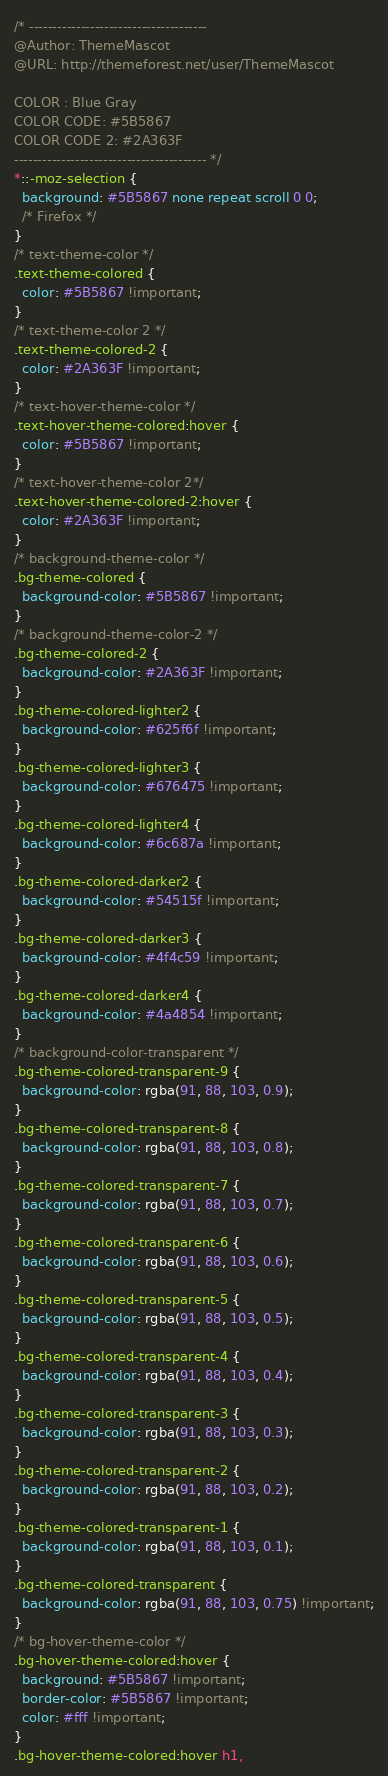Convert code to text. <code><loc_0><loc_0><loc_500><loc_500><_CSS_>/* --------------------------------------
@Author: ThemeMascot
@URL: http://themeforest.net/user/ThemeMascot

COLOR : Blue Gray
COLOR CODE: #5B5867
COLOR CODE 2: #2A363F
----------------------------------------- */
*::-moz-selection {
  background: #5B5867 none repeat scroll 0 0;
  /* Firefox */
}
/* text-theme-color */
.text-theme-colored {
  color: #5B5867 !important;
}
/* text-theme-color 2 */
.text-theme-colored-2 {
  color: #2A363F !important;
}
/* text-hover-theme-color */
.text-hover-theme-colored:hover {
  color: #5B5867 !important;
}
/* text-hover-theme-color 2*/
.text-hover-theme-colored-2:hover {
  color: #2A363F !important;
}
/* background-theme-color */
.bg-theme-colored {
  background-color: #5B5867 !important;
}
/* background-theme-color-2 */
.bg-theme-colored-2 {
  background-color: #2A363F !important;
}
.bg-theme-colored-lighter2 {
  background-color: #625f6f !important;
}
.bg-theme-colored-lighter3 {
  background-color: #676475 !important;
}
.bg-theme-colored-lighter4 {
  background-color: #6c687a !important;
}
.bg-theme-colored-darker2 {
  background-color: #54515f !important;
}
.bg-theme-colored-darker3 {
  background-color: #4f4c59 !important;
}
.bg-theme-colored-darker4 {
  background-color: #4a4854 !important;
}
/* background-color-transparent */
.bg-theme-colored-transparent-9 {
  background-color: rgba(91, 88, 103, 0.9);
}
.bg-theme-colored-transparent-8 {
  background-color: rgba(91, 88, 103, 0.8);
}
.bg-theme-colored-transparent-7 {
  background-color: rgba(91, 88, 103, 0.7);
}
.bg-theme-colored-transparent-6 {
  background-color: rgba(91, 88, 103, 0.6);
}
.bg-theme-colored-transparent-5 {
  background-color: rgba(91, 88, 103, 0.5);
}
.bg-theme-colored-transparent-4 {
  background-color: rgba(91, 88, 103, 0.4);
}
.bg-theme-colored-transparent-3 {
  background-color: rgba(91, 88, 103, 0.3);
}
.bg-theme-colored-transparent-2 {
  background-color: rgba(91, 88, 103, 0.2);
}
.bg-theme-colored-transparent-1 {
  background-color: rgba(91, 88, 103, 0.1);
}
.bg-theme-colored-transparent {
  background-color: rgba(91, 88, 103, 0.75) !important;
}
/* bg-hover-theme-color */
.bg-hover-theme-colored:hover {
  background: #5B5867 !important;
  border-color: #5B5867 !important;
  color: #fff !important;
}
.bg-hover-theme-colored:hover h1,</code> 